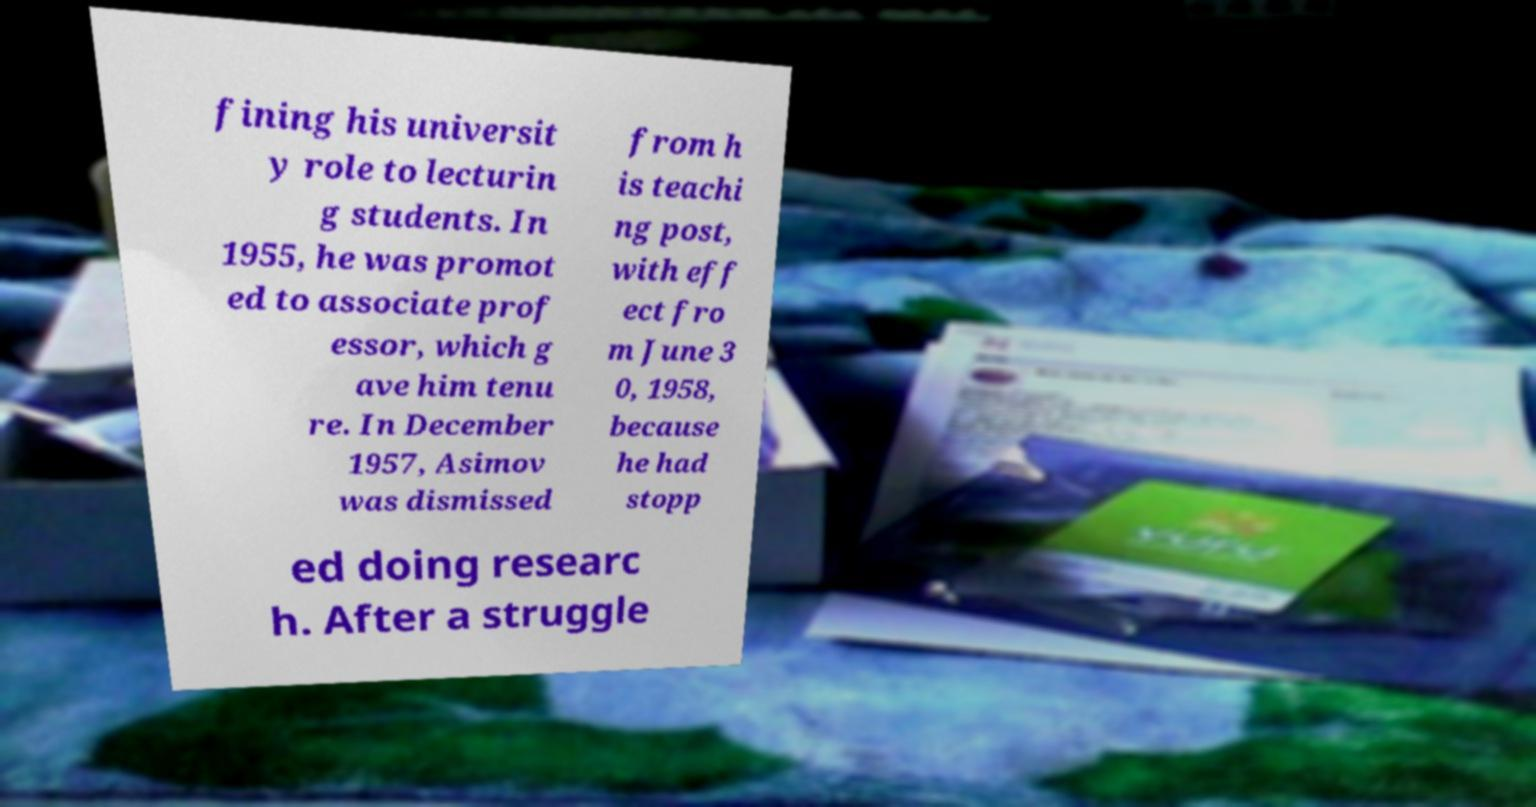There's text embedded in this image that I need extracted. Can you transcribe it verbatim? fining his universit y role to lecturin g students. In 1955, he was promot ed to associate prof essor, which g ave him tenu re. In December 1957, Asimov was dismissed from h is teachi ng post, with eff ect fro m June 3 0, 1958, because he had stopp ed doing researc h. After a struggle 